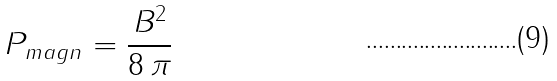<formula> <loc_0><loc_0><loc_500><loc_500>P _ { m a g n } = \frac { B ^ { 2 } } { 8 \, \pi }</formula> 